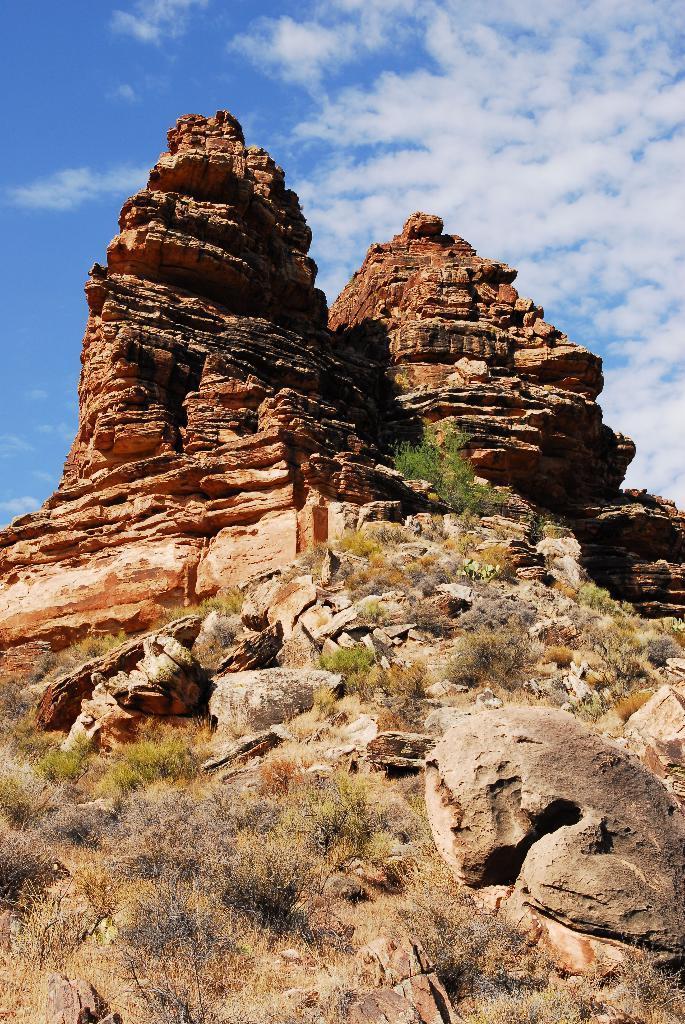Please provide a concise description of this image. In this image we can see rocks, shrubs and sky with clouds in the background. 